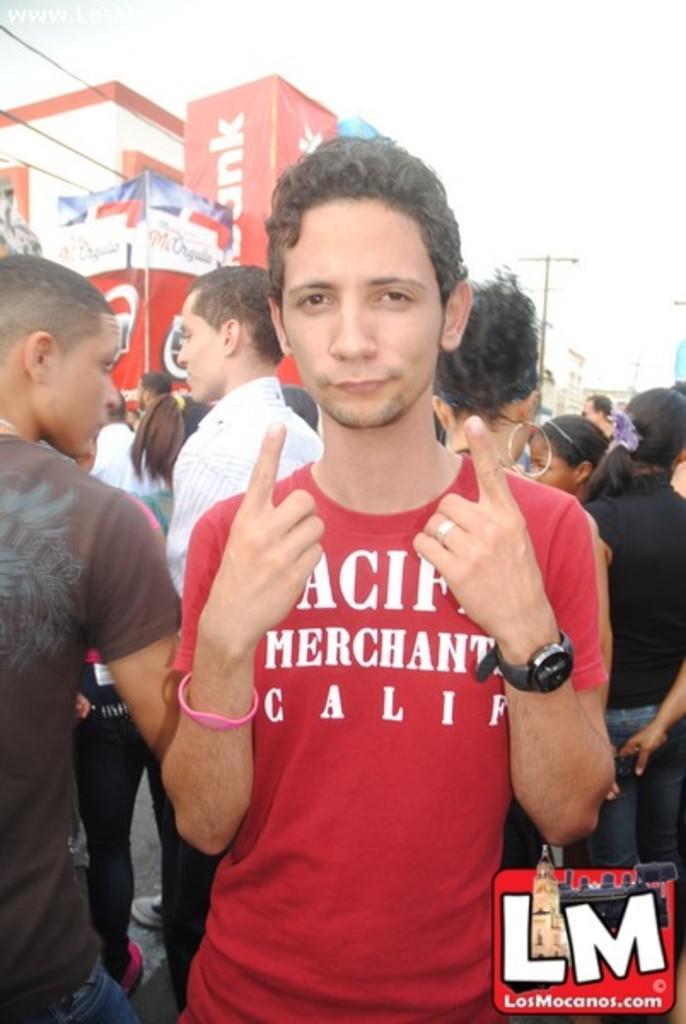How would you summarize this image in a sentence or two? In the image there is a person i red t-shirt showing fingers and behind there are many people standing on the road, on the background there is a building and above its sky. 